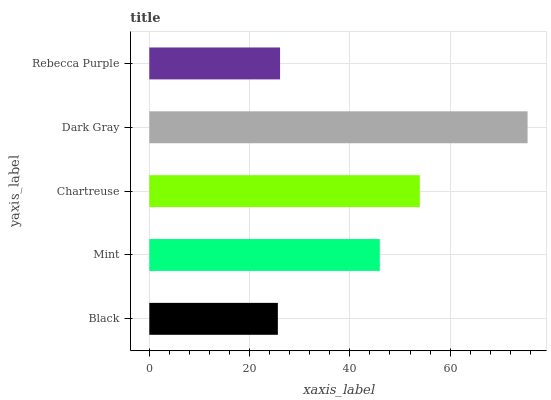Is Black the minimum?
Answer yes or no. Yes. Is Dark Gray the maximum?
Answer yes or no. Yes. Is Mint the minimum?
Answer yes or no. No. Is Mint the maximum?
Answer yes or no. No. Is Mint greater than Black?
Answer yes or no. Yes. Is Black less than Mint?
Answer yes or no. Yes. Is Black greater than Mint?
Answer yes or no. No. Is Mint less than Black?
Answer yes or no. No. Is Mint the high median?
Answer yes or no. Yes. Is Mint the low median?
Answer yes or no. Yes. Is Chartreuse the high median?
Answer yes or no. No. Is Chartreuse the low median?
Answer yes or no. No. 